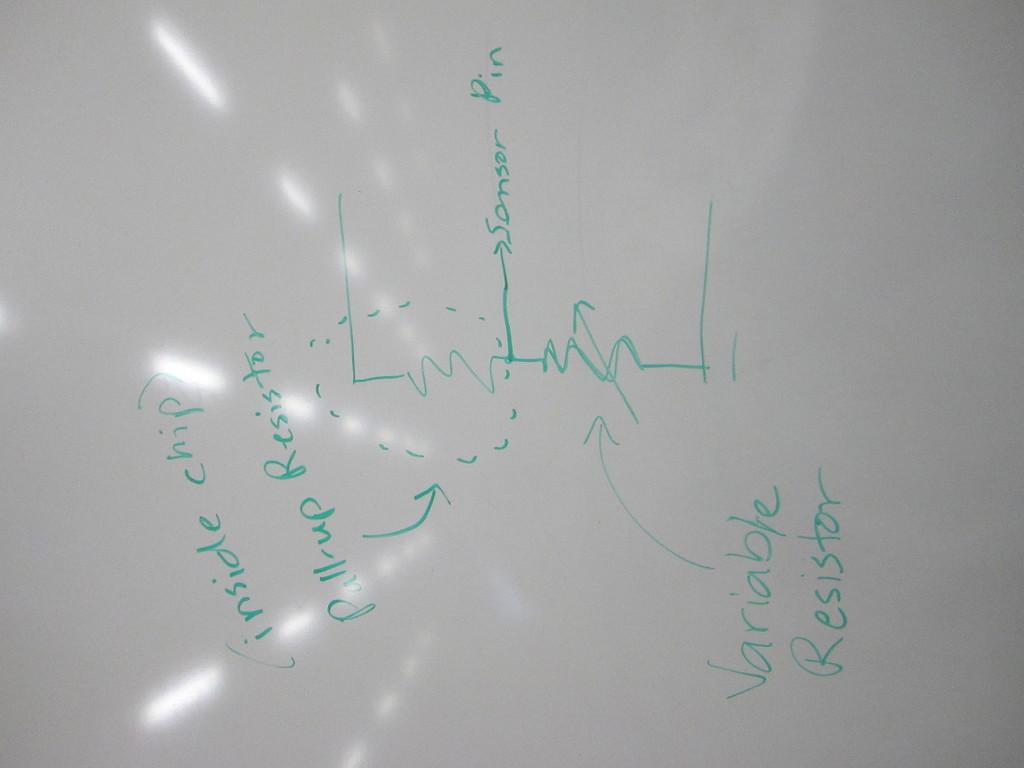How many resistors are there in the drawing?
Keep it short and to the point. 2. What type of resister is talked about on the right?
Your answer should be very brief. Variable. 